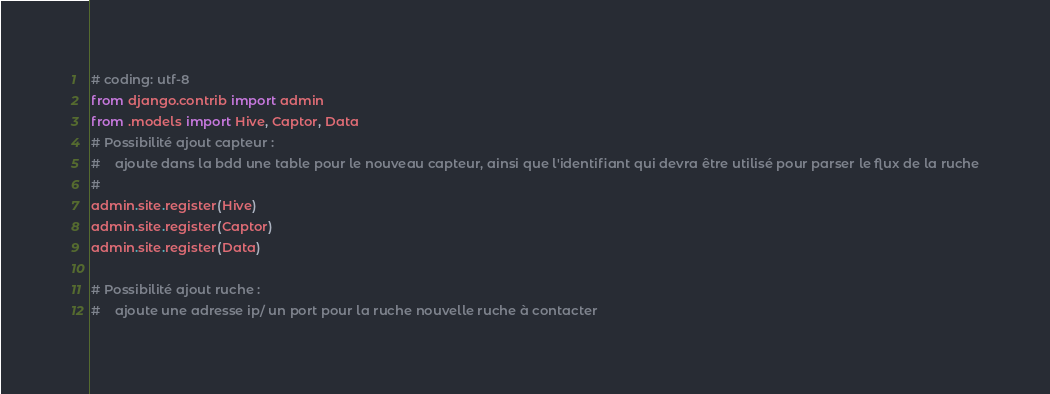Convert code to text. <code><loc_0><loc_0><loc_500><loc_500><_Python_># coding: utf-8
from django.contrib import admin
from .models import Hive, Captor, Data
# Possibilité ajout capteur :
#    ajoute dans la bdd une table pour le nouveau capteur, ainsi que l'identifiant qui devra être utilisé pour parser le flux de la ruche
#
admin.site.register(Hive)
admin.site.register(Captor)
admin.site.register(Data)

# Possibilité ajout ruche :
#    ajoute une adresse ip/ un port pour la ruche nouvelle ruche à contacter
</code> 